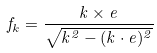<formula> <loc_0><loc_0><loc_500><loc_500>f _ { k } = \frac { k \times e } { \sqrt { k ^ { 2 } - ( k \cdot e ) ^ { 2 } } }</formula> 